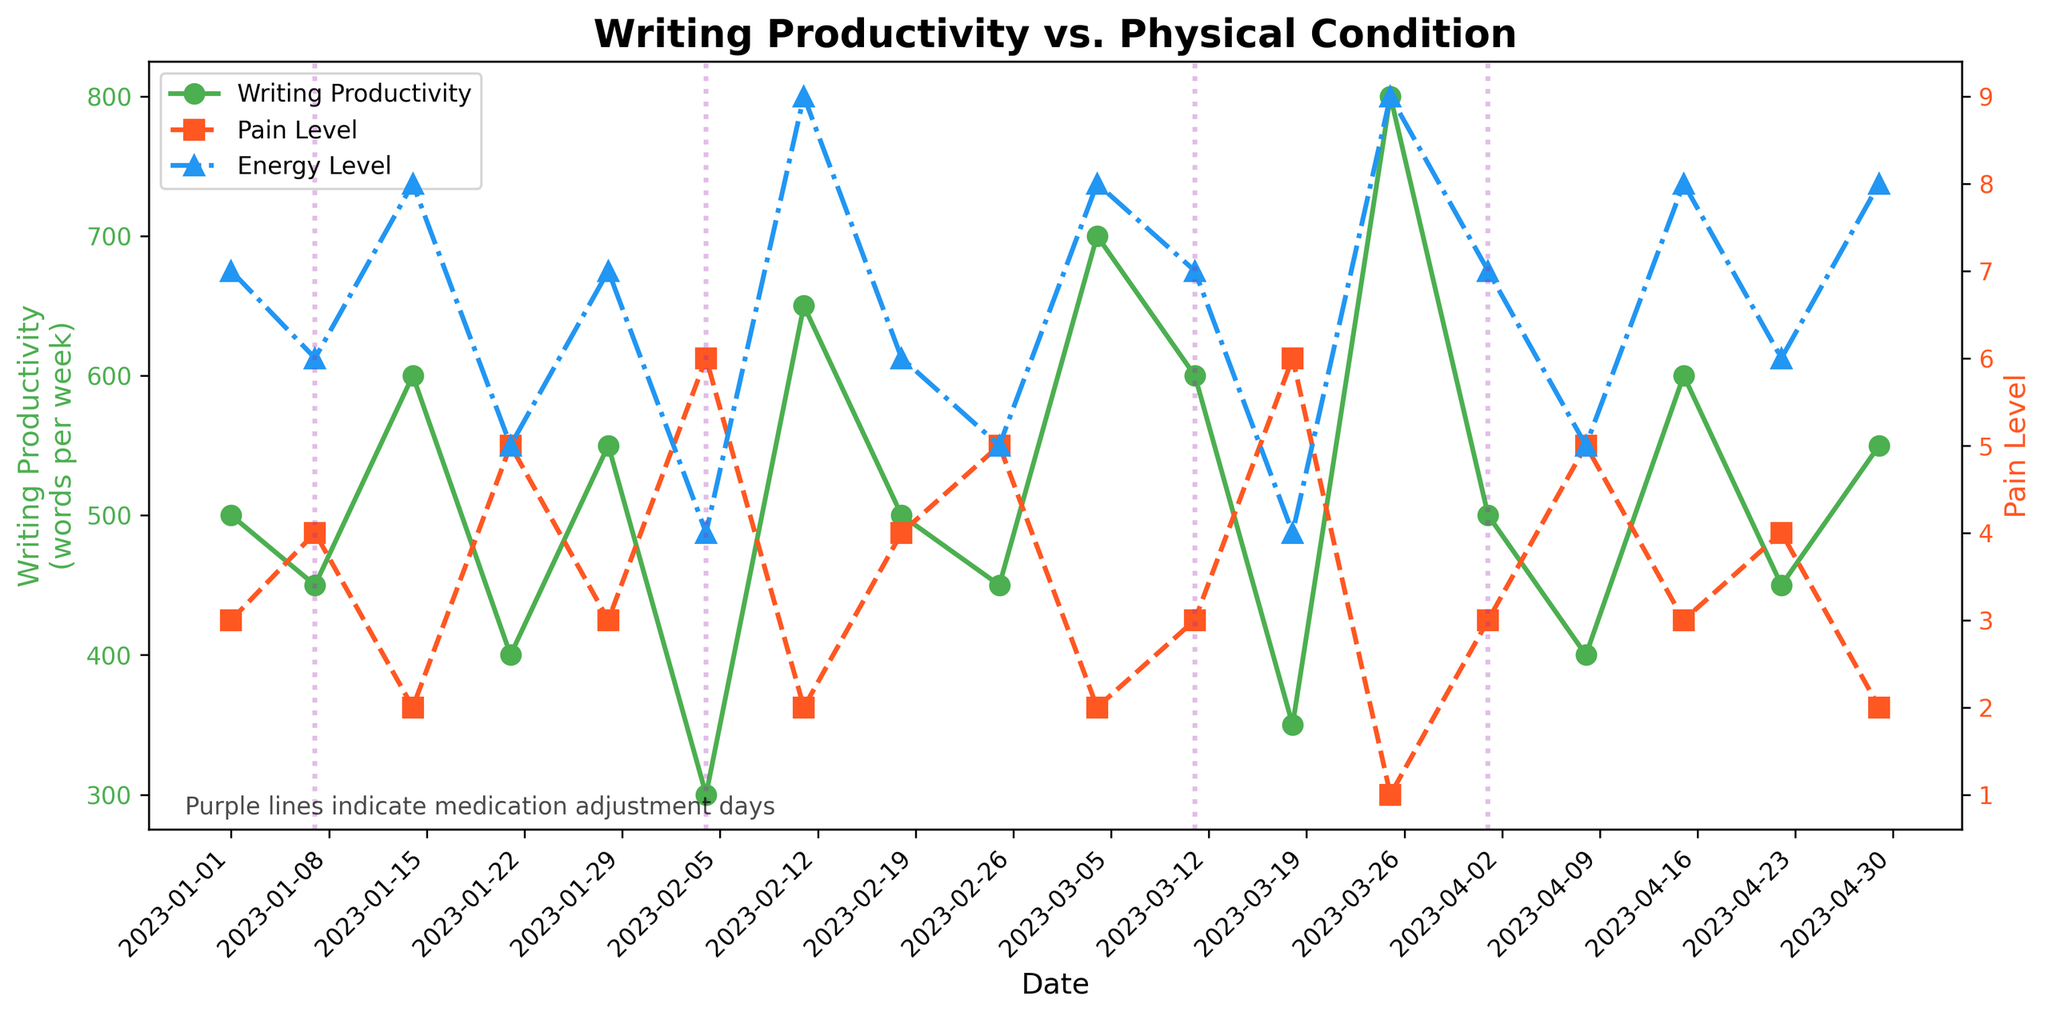What is the title of the figure? The title is typically displayed at the top of the figure and is clearly visible. In this case, it reads "Writing Productivity vs. Physical Condition."
Answer: Writing Productivity vs. Physical Condition What does the green line with circle markers represent? The green line with circle markers is associated with the left vertical axis, and according to the legend, it represents "Writing Productivity".
Answer: Writing Productivity How many medication adjustment days are indicated by vertical purple lines? The purple vertical lines indicate the days when medication adjustments occurred. By counting these lines in the figure, we observe that there are five such lines.
Answer: Five Which date shows the highest writing productivity, and what is its value? To find this, look for the peak in the green line and reference the associated date and value on the left vertical axis. The highest peak is on 2023-03-25 with a corresponding value of 800 words.
Answer: 2023-03-25, 800 How does the energy level on 2023-02-11 compare to the pain level on the same date? On 2023-02-11, the blue line (energy level) is at its maximum value and the red line (pain level) is at its minimum value. This indicates that the energy level is significantly higher than the pain level on this date.
Answer: Energy level is higher What is the general trend of writing productivity when the pain level increases? Observing the green line (writing productivity) and the red line (pain level), there seems to be a trend where increases in pain level are often accompanied by decreases in writing productivity.
Answer: Writing productivity decreases On days with medication adjustments, how does the writing productivity typically change? By examining the dates with vertical purple lines and corresponding changes in the green line (writing productivity), it appears that writing productivity doesn't follow a consistent pattern—it both increases and decreases.
Answer: No consistent pattern Calculate the average writing productivity over the provided timeframe. Sum all writing productivity values and divide by the number of data points. (500 + 450 + 600+ 400 + 550 + 300 + 650 + 500 + 450 + 700 + 600 + 350 + 800 + 500 + 400 + 600 + 450 + 550) / 17 =  531.76
Answer: 531.76 During which month does the energy level appear to fluctuate the most? Compare the blue line (energy level) across different months. Areas with larger spikes and dips indicate higher fluctuations. March shows the most fluctuation in the blue line.
Answer: March 